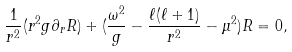<formula> <loc_0><loc_0><loc_500><loc_500>\frac { 1 } { r ^ { 2 } } ( r ^ { 2 } g \partial _ { r } R ) + ( \frac { \omega ^ { 2 } } { g } - \frac { \ell ( \ell + 1 ) } { r ^ { 2 } } - \mu ^ { 2 } ) R = 0 ,</formula> 